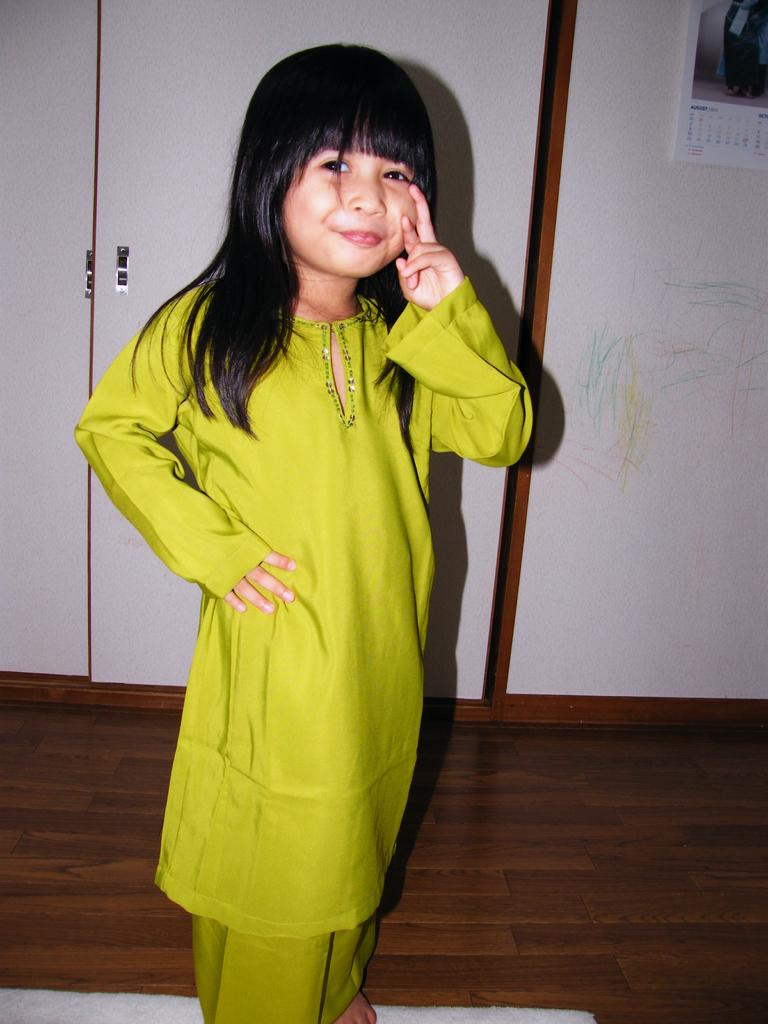What is the girl standing on in the image? The girl is standing on a mat. What can be seen at the bottom of the image? The floor is visible at the bottom of the image. What is hanging on the wall in the background? There is a calendar on the wall in the background. What type of furniture is present beside the wall? There are cupboards beside the wall. What crime is the girl committing in the image? There is no indication of a crime being committed in the image; the girl is simply standing on a mat. 